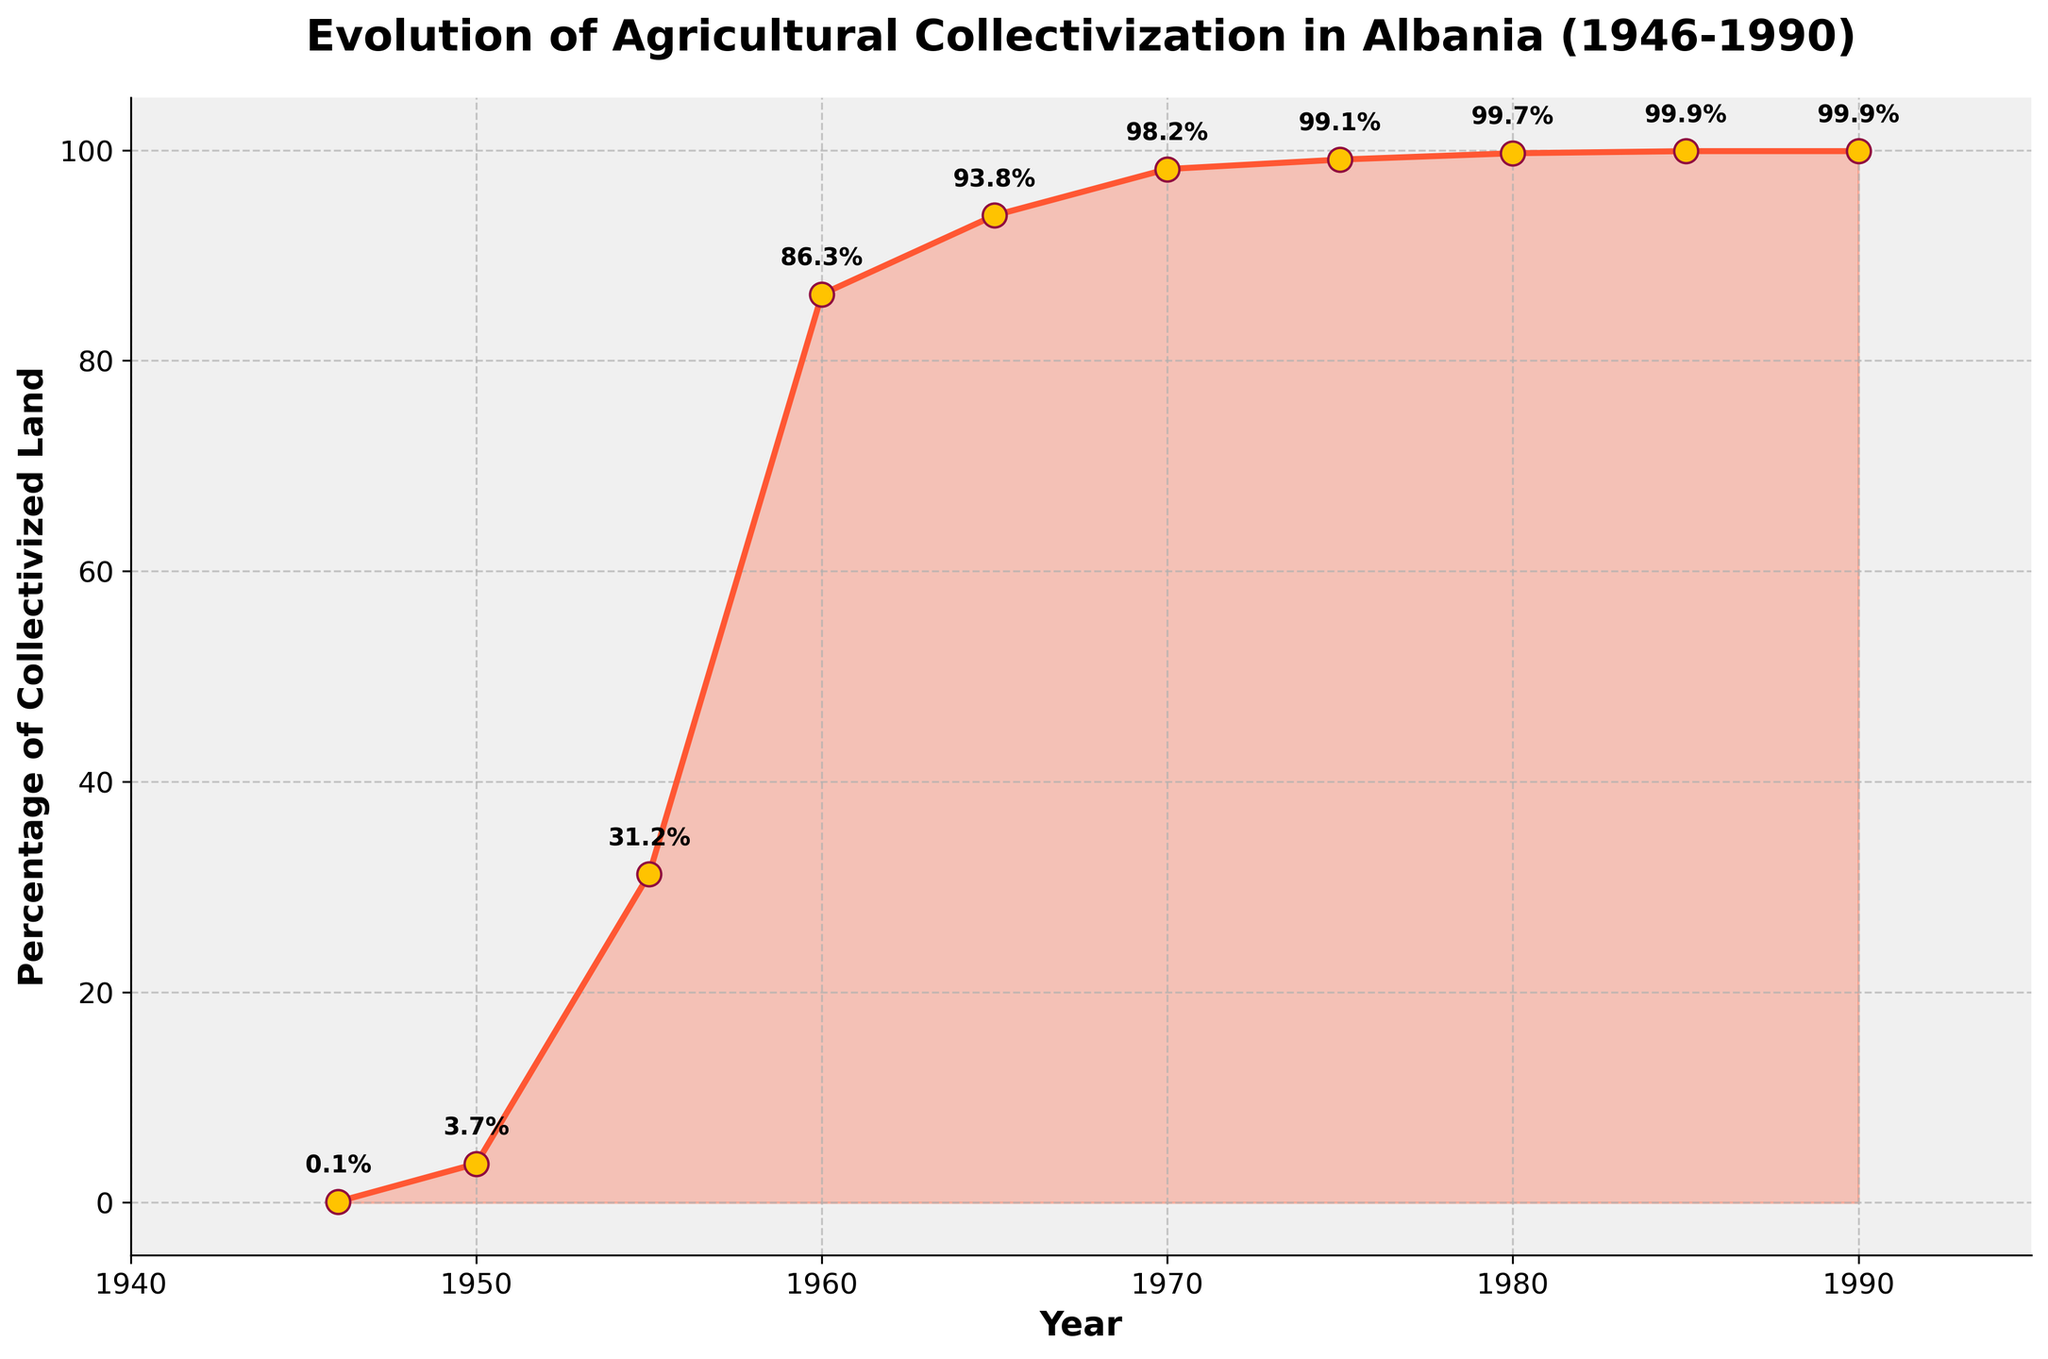What year did the percentage of collectivized land first exceed 50%? The percentage of collectivized land exceeded 50% in 1960. By examining the y-axis and corresponding x-axis values, we see that in 1960, the percentage reached 86.3%, which is beyond 50%.
Answer: 1960 In which decade did the majority of agricultural collectivization occur? Analyzing the slope of the line, the steepest increase happens from 1950 to 1960. During this period, the percentage of collectivized land rose dramatically from 3.7% to 86.3%.
Answer: 1950s Compare the percentage of collectivized land between 1970 and 1980. Which year had a higher percentage? Looking at the figure, in 1970, the percentage was 98.2%, and by 1980, it had increased to 99.7%. Thus, 1980 had a higher percentage of collectivized land.
Answer: 1980 How much did the percentage of collectivized land increase between 1946 and 1955? In 1946, the percentage was 0.1%, and in 1955, it was 31.2%. The increase can be calculated as 31.2% - 0.1% = 31.1%.
Answer: 31.1% What is the difference in the percentage of collectivized land between 1965 and 1990? In 1965, the percentage was 93.8%, and in 1990, it was 99.9%. The difference is calculated as 99.9% - 93.8% = 6.1%.
Answer: 6.1% From what year did the percentage of collectivized land stabilize around 99%? Observing the plot, starting from around 1975, the percentage of collectivized land remained consistently around 99%.
Answer: 1975 What is the average percentage of collectivized land from 1946 to 1990? The data points for the percentage of collectivized land are: 0.1, 3.7, 31.2, 86.3, 93.8, 98.2, 99.1, 99.7, 99.9, and 99.9. Calculating the average: (0.1 + 3.7 + 31.2 + 86.3 + 93.8 + 98.2 + 99.1 + 99.7 + 99.9 + 99.9) / 10 = 71.19%.
Answer: 71.19% What trend do you observe in the percentage of collectivized land from 1960 onwards? From 1960 onwards, the trend shows a steady increase in the percentage of collectivized land until it mostly stabilizes around 99% starting from 1975.
Answer: Steady increase until stabilization in 1975 